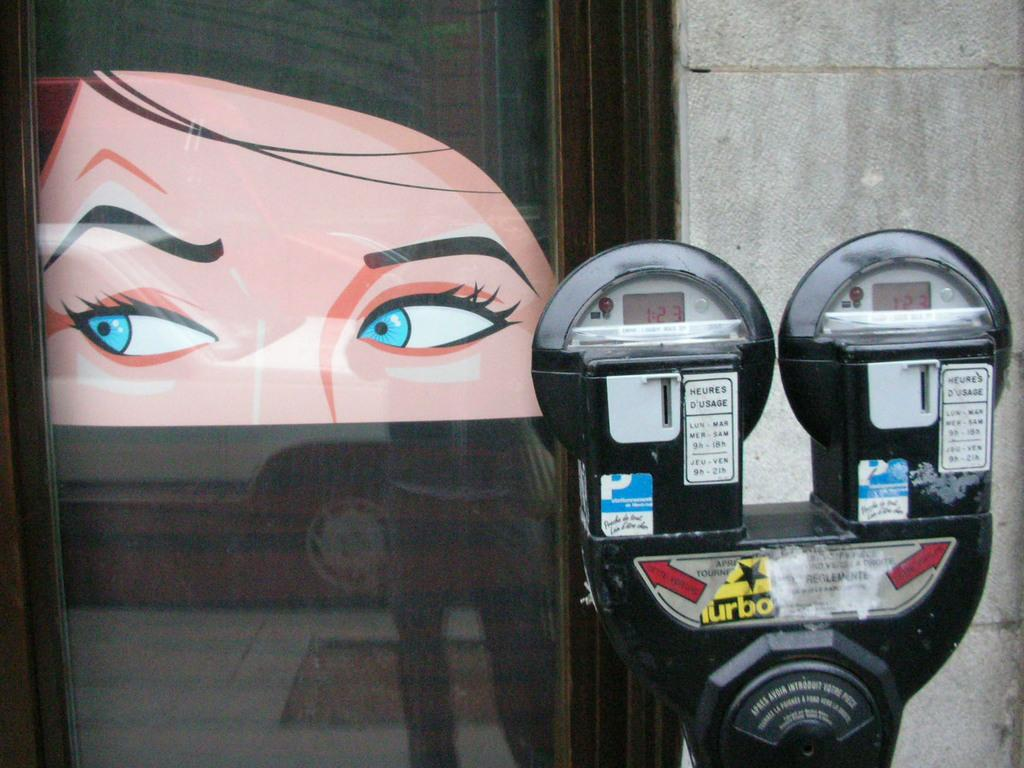<image>
Create a compact narrative representing the image presented. parking meters with red display showing 1:23 on them and drawing of a womans head in window behind meters 